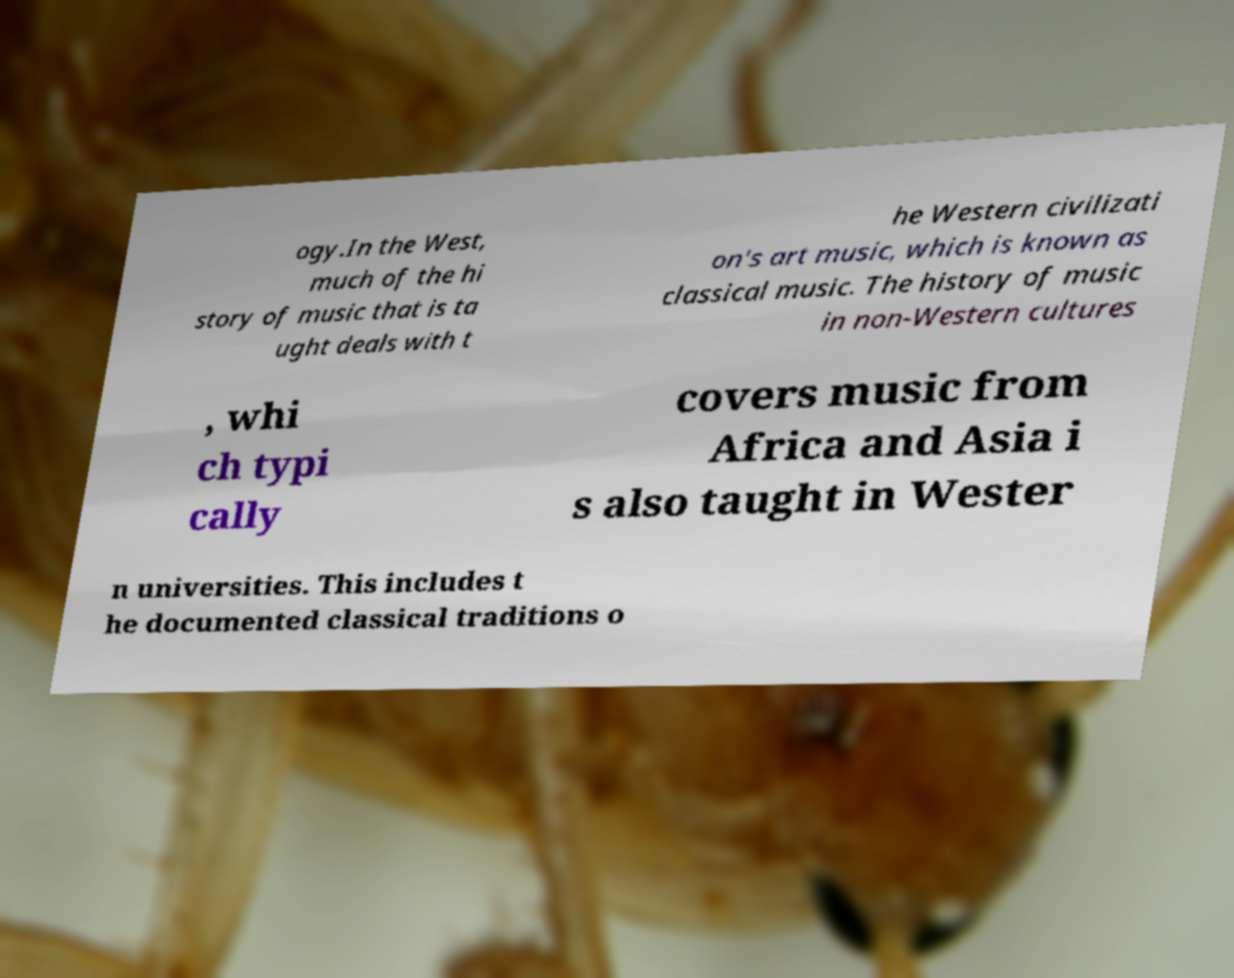Can you read and provide the text displayed in the image?This photo seems to have some interesting text. Can you extract and type it out for me? ogy.In the West, much of the hi story of music that is ta ught deals with t he Western civilizati on's art music, which is known as classical music. The history of music in non-Western cultures , whi ch typi cally covers music from Africa and Asia i s also taught in Wester n universities. This includes t he documented classical traditions o 